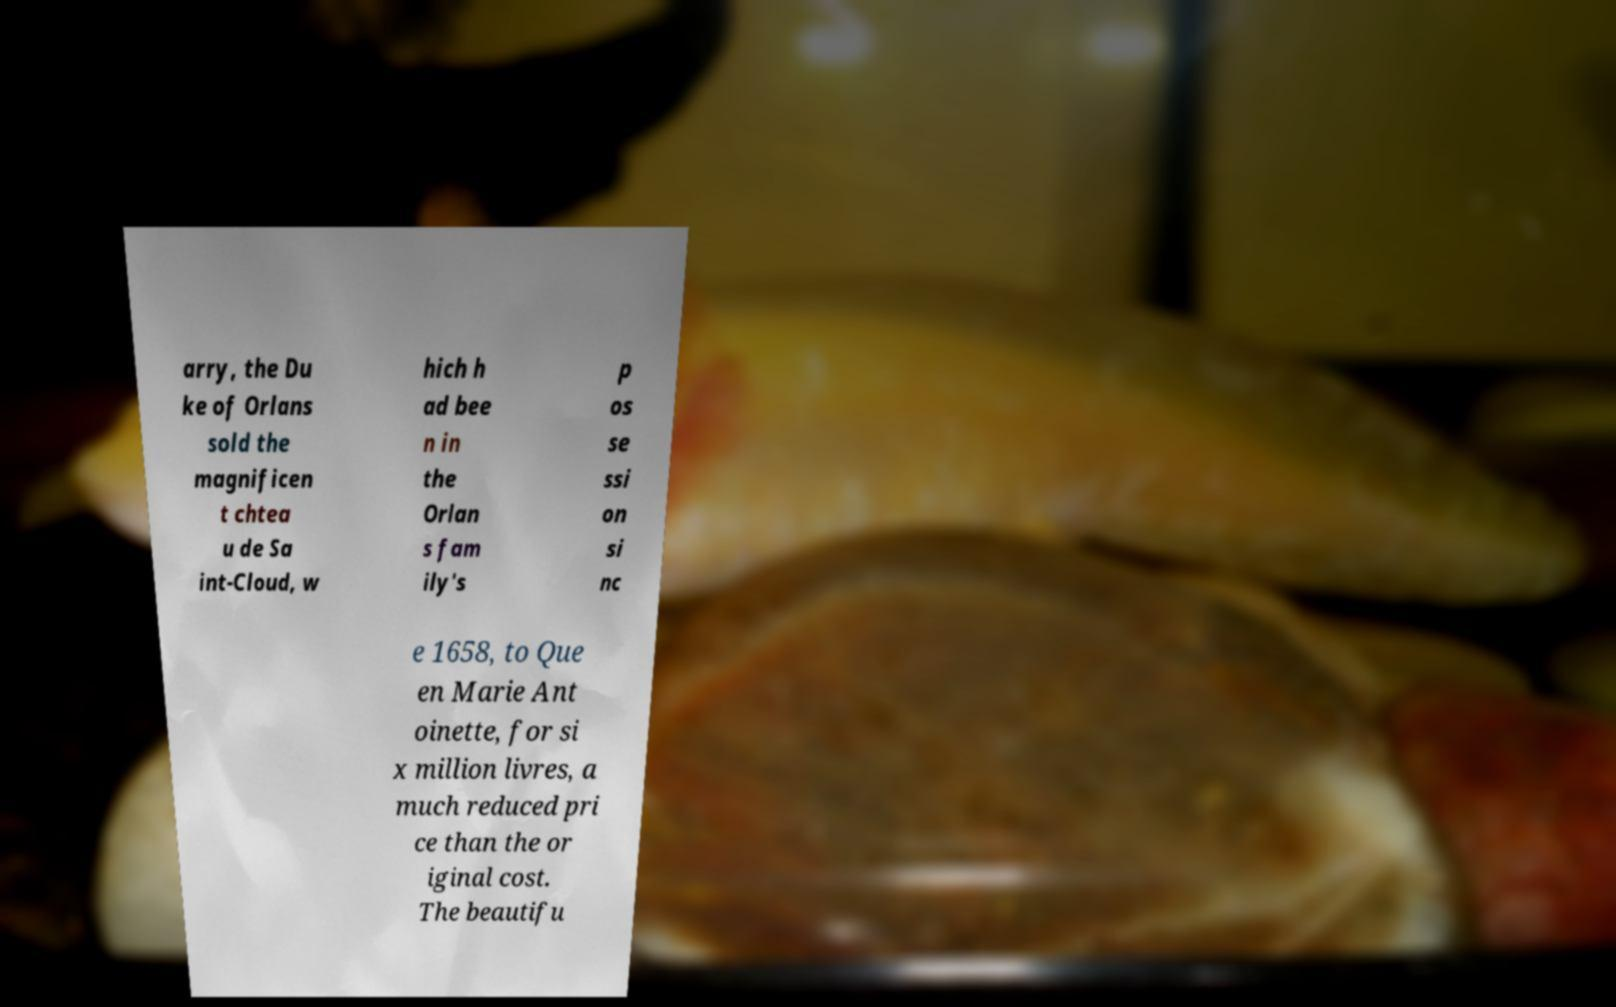Could you extract and type out the text from this image? arry, the Du ke of Orlans sold the magnificen t chtea u de Sa int-Cloud, w hich h ad bee n in the Orlan s fam ily's p os se ssi on si nc e 1658, to Que en Marie Ant oinette, for si x million livres, a much reduced pri ce than the or iginal cost. The beautifu 